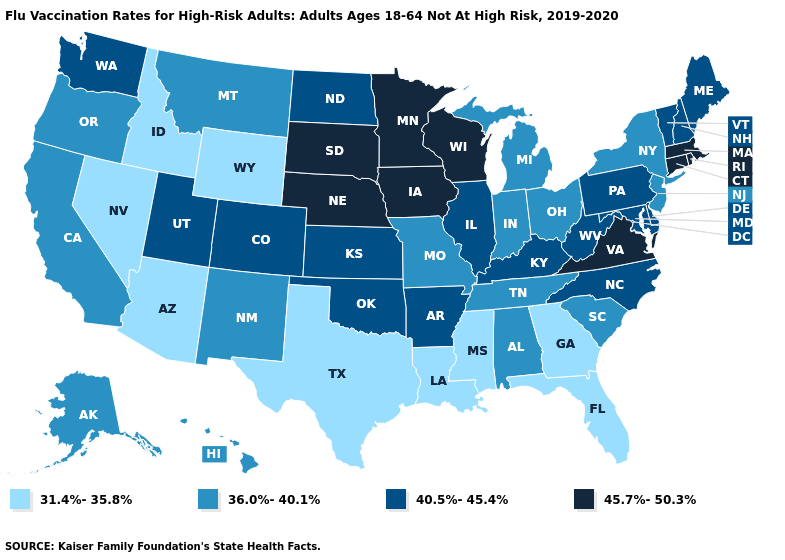Which states have the lowest value in the Northeast?
Keep it brief. New Jersey, New York. Does Wisconsin have the lowest value in the MidWest?
Concise answer only. No. Which states have the lowest value in the South?
Concise answer only. Florida, Georgia, Louisiana, Mississippi, Texas. What is the value of California?
Short answer required. 36.0%-40.1%. What is the lowest value in the USA?
Keep it brief. 31.4%-35.8%. Does South Carolina have a lower value than Arizona?
Keep it brief. No. What is the value of Wisconsin?
Quick response, please. 45.7%-50.3%. Name the states that have a value in the range 45.7%-50.3%?
Concise answer only. Connecticut, Iowa, Massachusetts, Minnesota, Nebraska, Rhode Island, South Dakota, Virginia, Wisconsin. What is the highest value in the USA?
Quick response, please. 45.7%-50.3%. What is the lowest value in states that border Colorado?
Short answer required. 31.4%-35.8%. What is the value of California?
Short answer required. 36.0%-40.1%. Does Wisconsin have the lowest value in the USA?
Write a very short answer. No. Name the states that have a value in the range 31.4%-35.8%?
Write a very short answer. Arizona, Florida, Georgia, Idaho, Louisiana, Mississippi, Nevada, Texas, Wyoming. Among the states that border New Jersey , which have the lowest value?
Give a very brief answer. New York. 